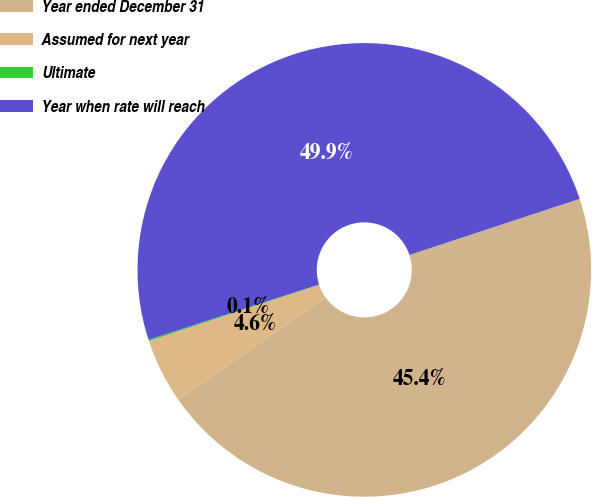Convert chart to OTSL. <chart><loc_0><loc_0><loc_500><loc_500><pie_chart><fcel>Year ended December 31<fcel>Assumed for next year<fcel>Ultimate<fcel>Year when rate will reach<nl><fcel>45.37%<fcel>4.63%<fcel>0.09%<fcel>49.91%<nl></chart> 